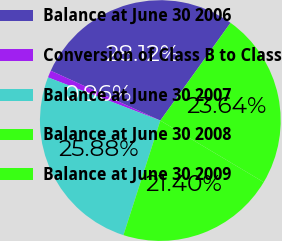Convert chart to OTSL. <chart><loc_0><loc_0><loc_500><loc_500><pie_chart><fcel>Balance at June 30 2006<fcel>Conversion of Class B to Class<fcel>Balance at June 30 2007<fcel>Balance at June 30 2008<fcel>Balance at June 30 2009<nl><fcel>28.12%<fcel>0.96%<fcel>25.88%<fcel>21.4%<fcel>23.64%<nl></chart> 